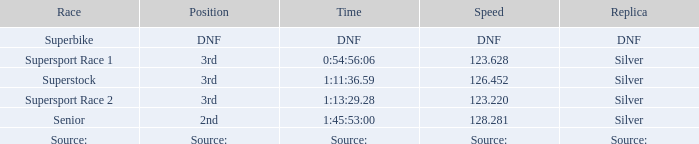Which race has a position of 3rd and a speed of 126.452? Superstock. 